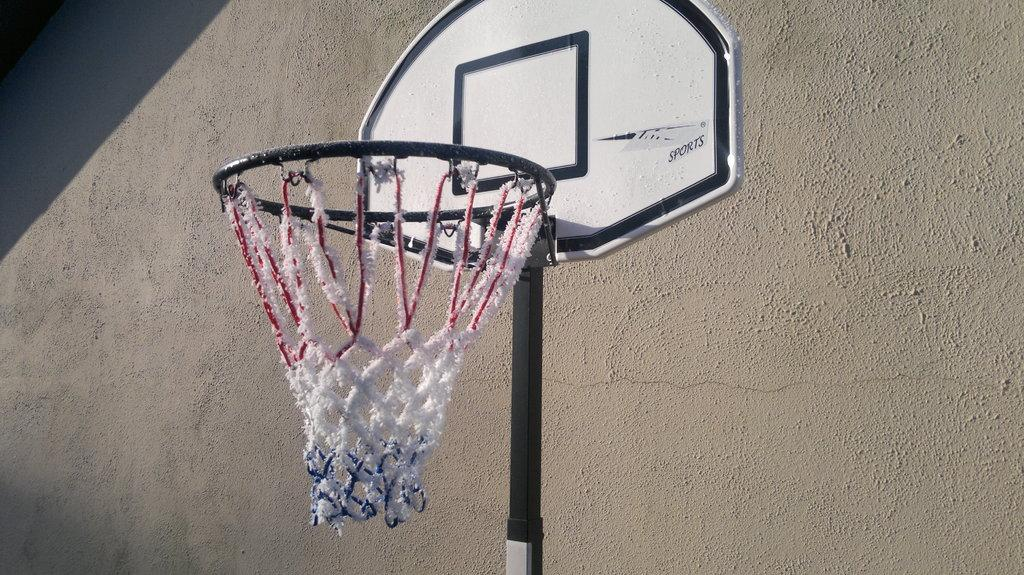What type of sports equipment is present in the image? There is a basketball net in the image. What is located on the right side of the image? There is a wall on the right side of the image. What type of twig can be seen growing on the wall in the image? There is no twig present on the wall in the image. What type of office equipment can be seen in the image? There is no office equipment present in the image. What type of tool is being used to fix the basketball net in the image? There is no tool present in the image, and the basketball net does not appear to be in need of repair. 